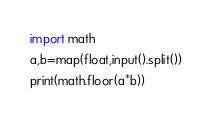<code> <loc_0><loc_0><loc_500><loc_500><_Python_>import math
a,b=map(float,input().split())
print(math.floor(a*b))</code> 